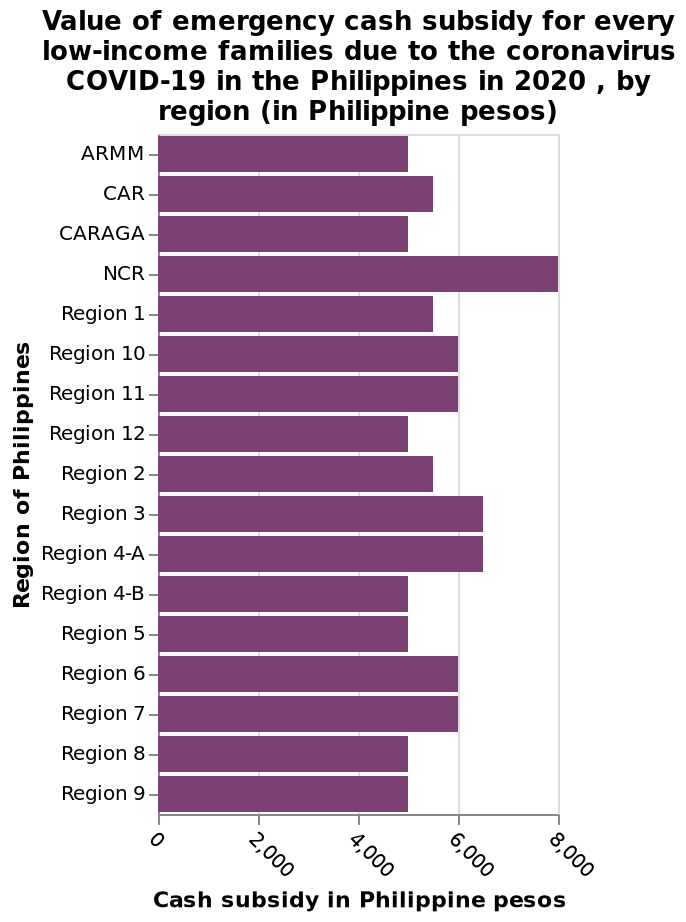<image>
Which regions received the lowest cash subsidy? The regions that received the lowest cash subsidy were ARM, CARAGA, and Regions 12, 4B, 5, 8, and 9. How much cash subsidy did NCR receive? NCR received a cash subsidy of 8000 pesos. What was the largest cash subsidy given and to which region? The largest cash subsidy was to NCR and it was worth 8000 pesos. 